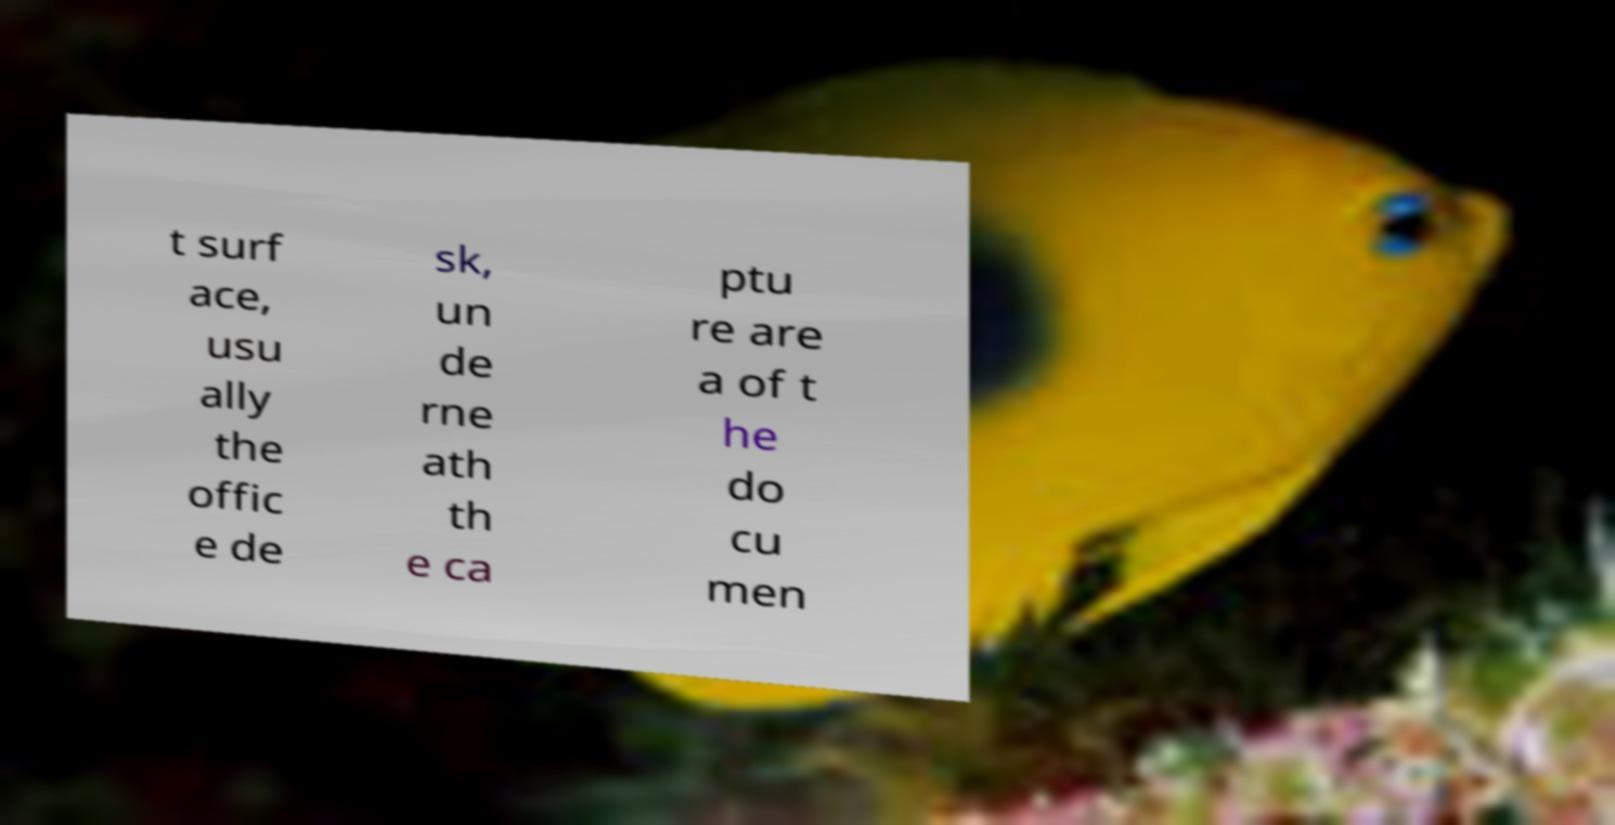There's text embedded in this image that I need extracted. Can you transcribe it verbatim? t surf ace, usu ally the offic e de sk, un de rne ath th e ca ptu re are a of t he do cu men 